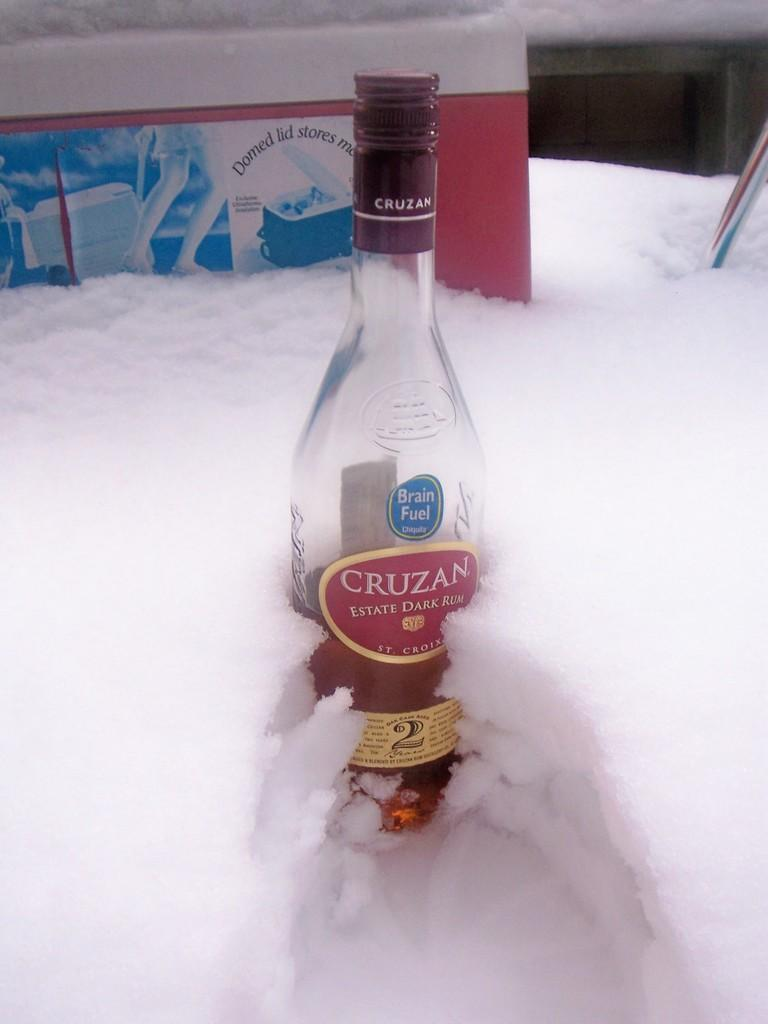<image>
Describe the image concisely. A bottle of Cruzan is in front of a Domed Lid Store product. 